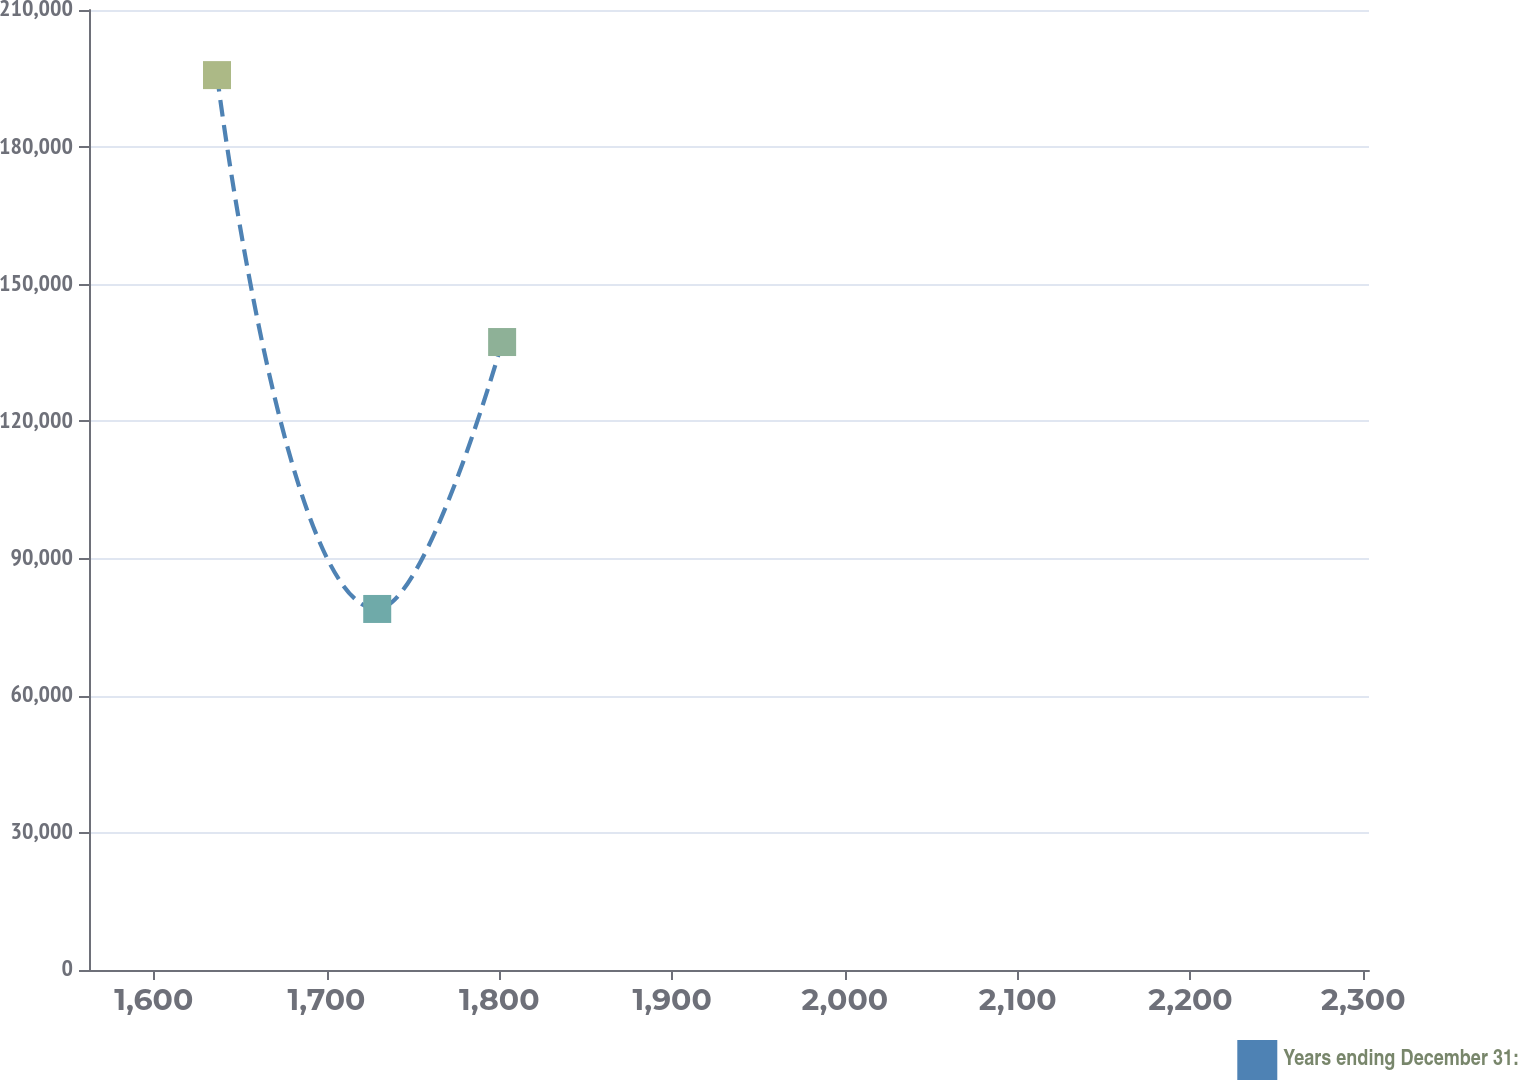<chart> <loc_0><loc_0><loc_500><loc_500><line_chart><ecel><fcel>Years ending December 31:<nl><fcel>1636.6<fcel>195758<nl><fcel>1729.33<fcel>78977.6<nl><fcel>1801.62<fcel>137368<nl><fcel>2305.13<fcel>20587.5<nl><fcel>2377.41<fcel>604488<nl></chart> 